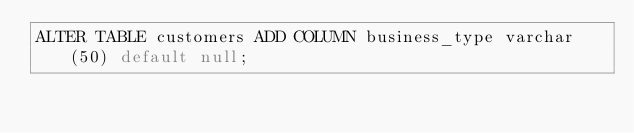Convert code to text. <code><loc_0><loc_0><loc_500><loc_500><_SQL_>ALTER TABLE customers ADD COLUMN business_type varchar(50) default null;
</code> 